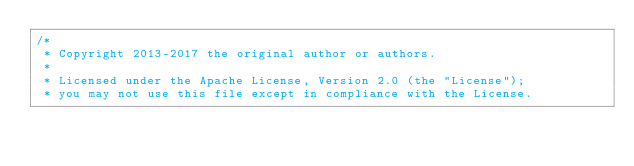<code> <loc_0><loc_0><loc_500><loc_500><_Java_>/*
 * Copyright 2013-2017 the original author or authors.
 *
 * Licensed under the Apache License, Version 2.0 (the "License");
 * you may not use this file except in compliance with the License.</code> 